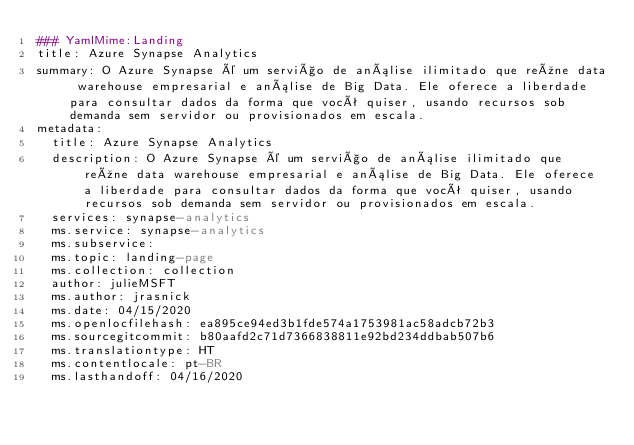<code> <loc_0><loc_0><loc_500><loc_500><_YAML_>### YamlMime:Landing
title: Azure Synapse Analytics
summary: O Azure Synapse é um serviço de análise ilimitado que reúne data warehouse empresarial e análise de Big Data. Ele oferece a liberdade para consultar dados da forma que você quiser, usando recursos sob demanda sem servidor ou provisionados em escala.
metadata:
  title: Azure Synapse Analytics
  description: O Azure Synapse é um serviço de análise ilimitado que reúne data warehouse empresarial e análise de Big Data. Ele oferece a liberdade para consultar dados da forma que você quiser, usando recursos sob demanda sem servidor ou provisionados em escala.
  services: synapse-analytics
  ms.service: synapse-analytics
  ms.subservice: 
  ms.topic: landing-page
  ms.collection: collection
  author: julieMSFT
  ms.author: jrasnick
  ms.date: 04/15/2020
  ms.openlocfilehash: ea895ce94ed3b1fde574a1753981ac58adcb72b3
  ms.sourcegitcommit: b80aafd2c71d7366838811e92bd234ddbab507b6
  ms.translationtype: HT
  ms.contentlocale: pt-BR
  ms.lasthandoff: 04/16/2020</code> 